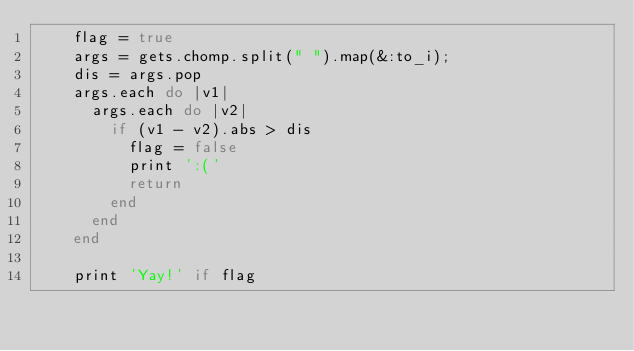Convert code to text. <code><loc_0><loc_0><loc_500><loc_500><_Ruby_>    flag = true
    args = gets.chomp.split(" ").map(&:to_i);
    dis = args.pop
    args.each do |v1|
      args.each do |v2|
        if (v1 - v2).abs > dis
          flag = false
          print ':('
          return 
        end
      end
    end

    print 'Yay!' if flag</code> 